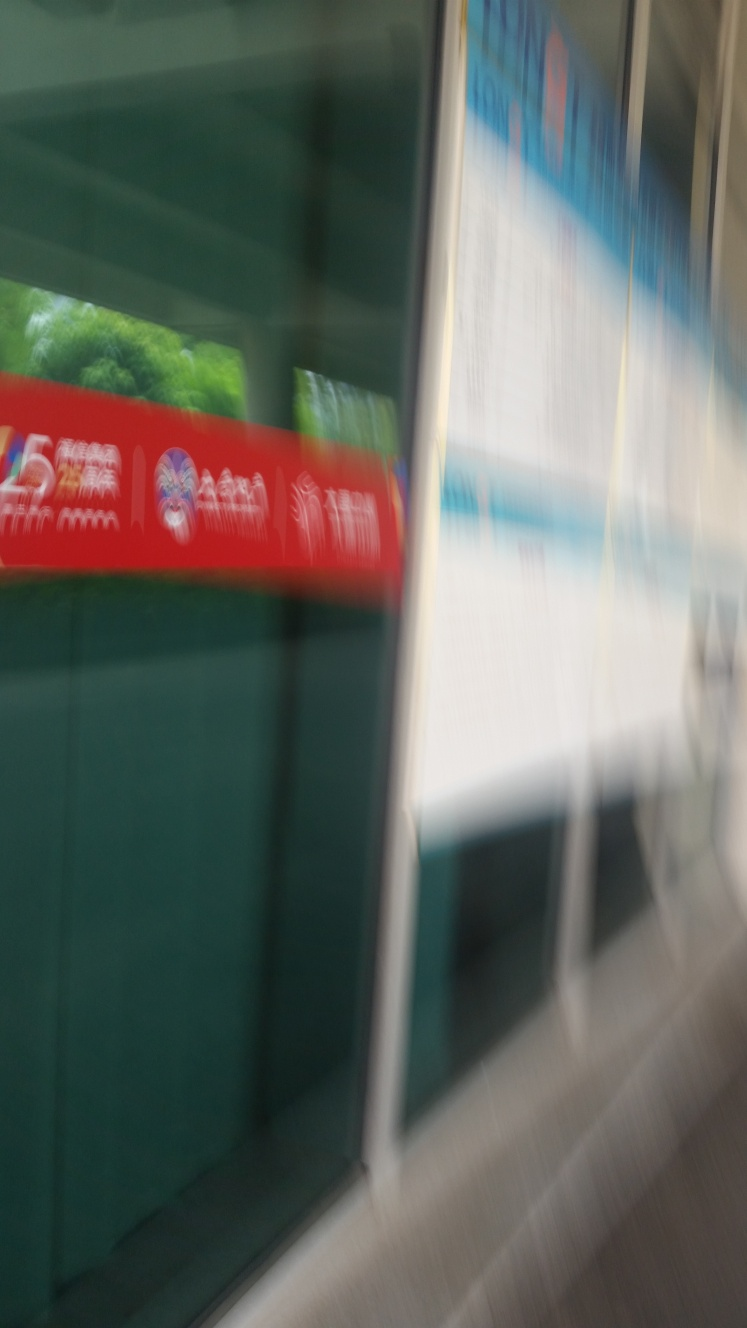What could be the cause of the blur in this image? The blur is most likely caused by taking a photograph with a slow shutter speed while in motion, such as shooting from inside a moving vehicle, or capturing a fast-moving subject from a static position. It's also possible that it was a quick hand movement while taking the photo. Is there any artistic value or use for an image like this? Absolutely, artistic value can be found in unconventional forms such as this blurred image. It can be used to portray motion, speed, and the flow of time. In the right context, it might contribute to thematic elements in various creative projects like abstract art, representing the concept of movement or the city's rhythm. 